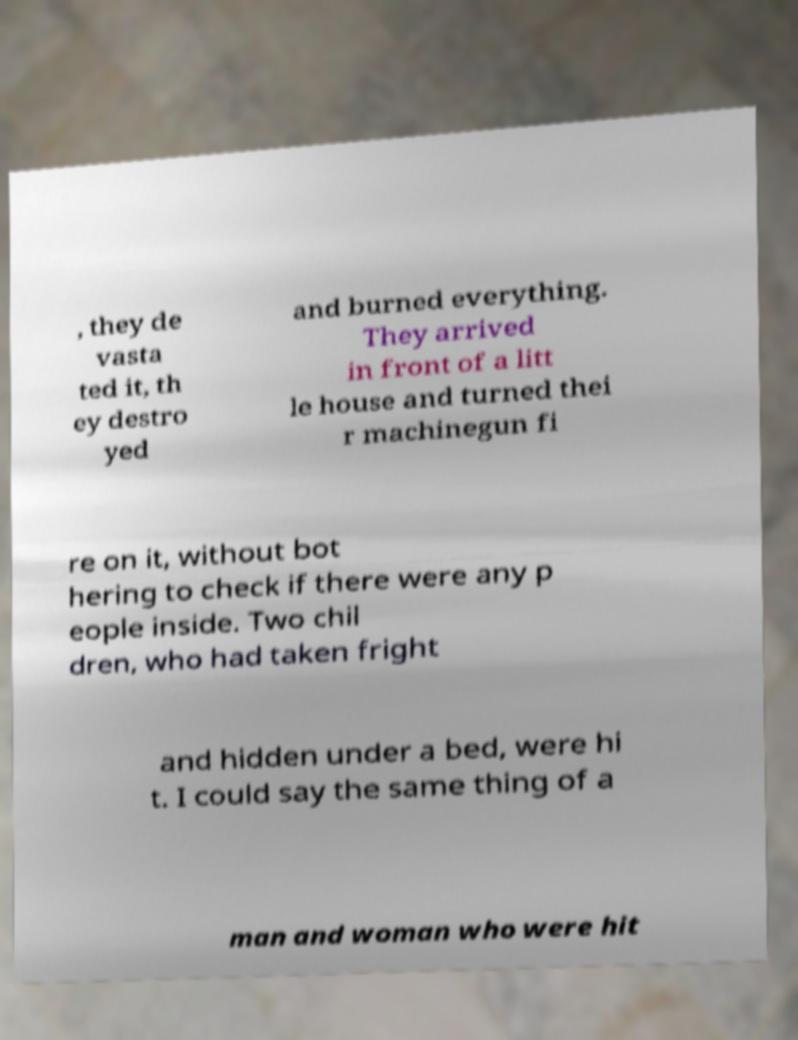Please identify and transcribe the text found in this image. , they de vasta ted it, th ey destro yed and burned everything. They arrived in front of a litt le house and turned thei r machinegun fi re on it, without bot hering to check if there were any p eople inside. Two chil dren, who had taken fright and hidden under a bed, were hi t. I could say the same thing of a man and woman who were hit 